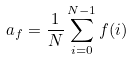Convert formula to latex. <formula><loc_0><loc_0><loc_500><loc_500>a _ { f } = \frac { 1 } { N } \sum _ { i = 0 } ^ { N - 1 } f ( i )</formula> 